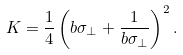<formula> <loc_0><loc_0><loc_500><loc_500>K = \frac { 1 } { 4 } \left ( b \sigma _ { \bot } + \frac { 1 } { b \sigma _ { \bot } } \right ) ^ { 2 } .</formula> 